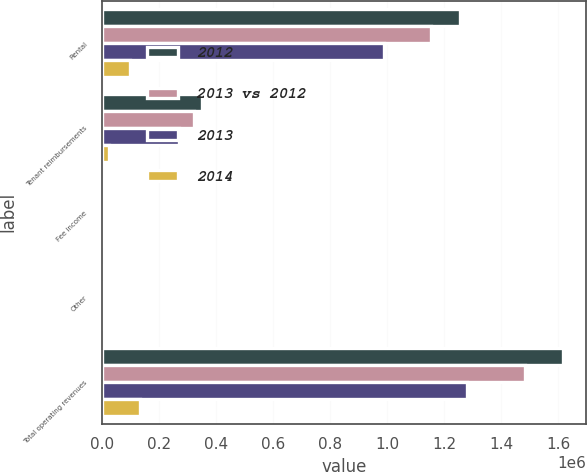Convert chart. <chart><loc_0><loc_0><loc_500><loc_500><stacked_bar_chart><ecel><fcel>Rental<fcel>Tenant reimbursements<fcel>Fee income<fcel>Other<fcel>Total operating revenues<nl><fcel>2012<fcel>1.25609e+06<fcel>350234<fcel>7268<fcel>2850<fcel>1.61644e+06<nl><fcel>2013 vs 2012<fcel>1.15505e+06<fcel>323286<fcel>3520<fcel>402<fcel>1.48226e+06<nl><fcel>2013<fcel>990715<fcel>272309<fcel>8428<fcel>7615<fcel>1.27907e+06<nl><fcel>2014<fcel>101035<fcel>26948<fcel>3748<fcel>2448<fcel>134179<nl></chart> 